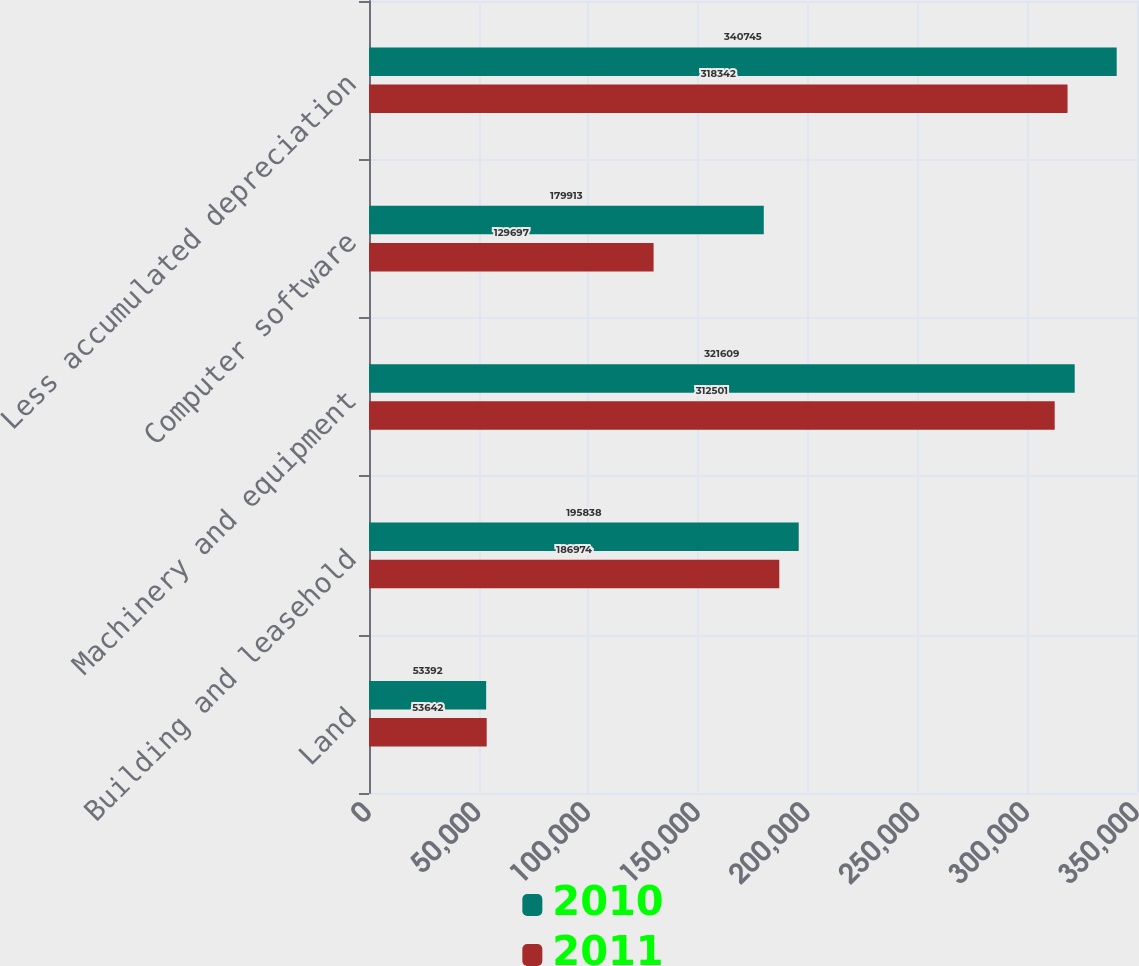Convert chart to OTSL. <chart><loc_0><loc_0><loc_500><loc_500><stacked_bar_chart><ecel><fcel>Land<fcel>Building and leasehold<fcel>Machinery and equipment<fcel>Computer software<fcel>Less accumulated depreciation<nl><fcel>2010<fcel>53392<fcel>195838<fcel>321609<fcel>179913<fcel>340745<nl><fcel>2011<fcel>53642<fcel>186974<fcel>312501<fcel>129697<fcel>318342<nl></chart> 